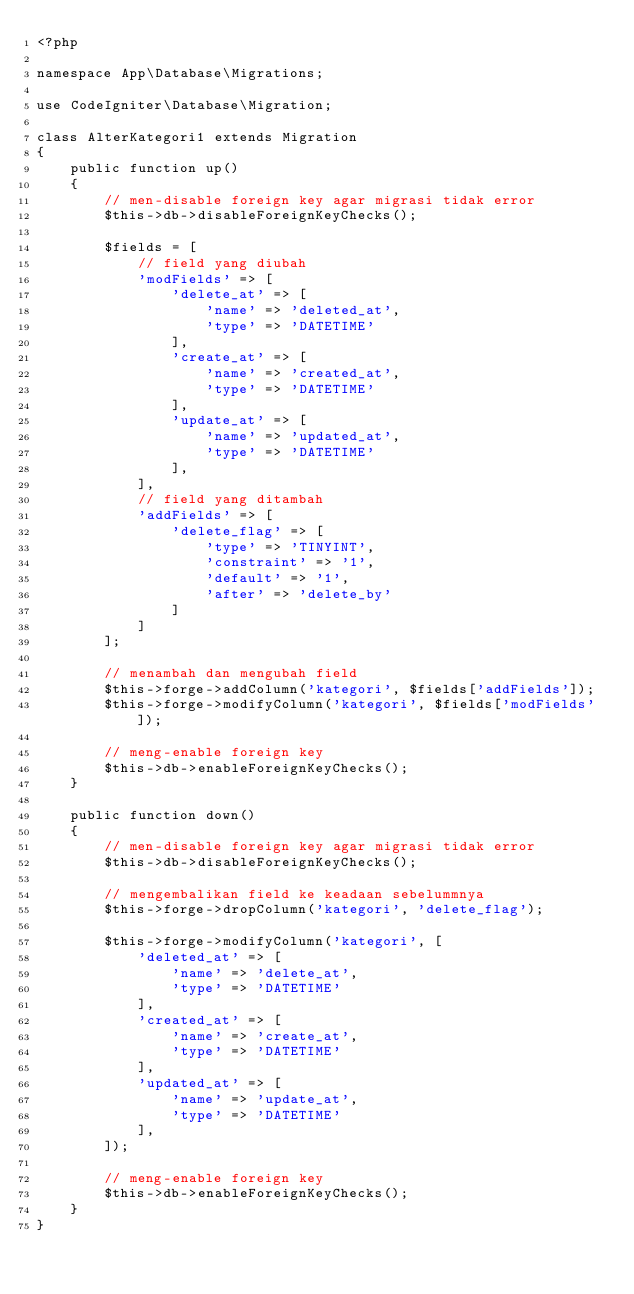Convert code to text. <code><loc_0><loc_0><loc_500><loc_500><_PHP_><?php

namespace App\Database\Migrations;

use CodeIgniter\Database\Migration;

class AlterKategori1 extends Migration
{
    public function up()
    {
        // men-disable foreign key agar migrasi tidak error
        $this->db->disableForeignKeyChecks();

        $fields = [
            // field yang diubah
            'modFields' => [
                'delete_at' => [
                    'name' => 'deleted_at',
                    'type' => 'DATETIME'
                ],
                'create_at' => [
                    'name' => 'created_at',
                    'type' => 'DATETIME'
                ],
                'update_at' => [
                    'name' => 'updated_at',
                    'type' => 'DATETIME'
                ],
            ],
            // field yang ditambah
            'addFields' => [
                'delete_flag' => [
                    'type' => 'TINYINT',
                    'constraint' => '1',
                    'default' => '1',
                    'after' => 'delete_by'
                ]
            ]
        ];
        
        // menambah dan mengubah field
        $this->forge->addColumn('kategori', $fields['addFields']);
        $this->forge->modifyColumn('kategori', $fields['modFields']);

        // meng-enable foreign key
        $this->db->enableForeignKeyChecks();
    }

    public function down()
    {
        // men-disable foreign key agar migrasi tidak error
        $this->db->disableForeignKeyChecks();

        // mengembalikan field ke keadaan sebelummnya
        $this->forge->dropColumn('kategori', 'delete_flag');

        $this->forge->modifyColumn('kategori', [
            'deleted_at' => [
                'name' => 'delete_at',
                'type' => 'DATETIME'
            ],
            'created_at' => [
                'name' => 'create_at',
                'type' => 'DATETIME'
            ],
            'updated_at' => [
                'name' => 'update_at',
                'type' => 'DATETIME'
            ],
        ]);
        
        // meng-enable foreign key
        $this->db->enableForeignKeyChecks();
    }
}
</code> 